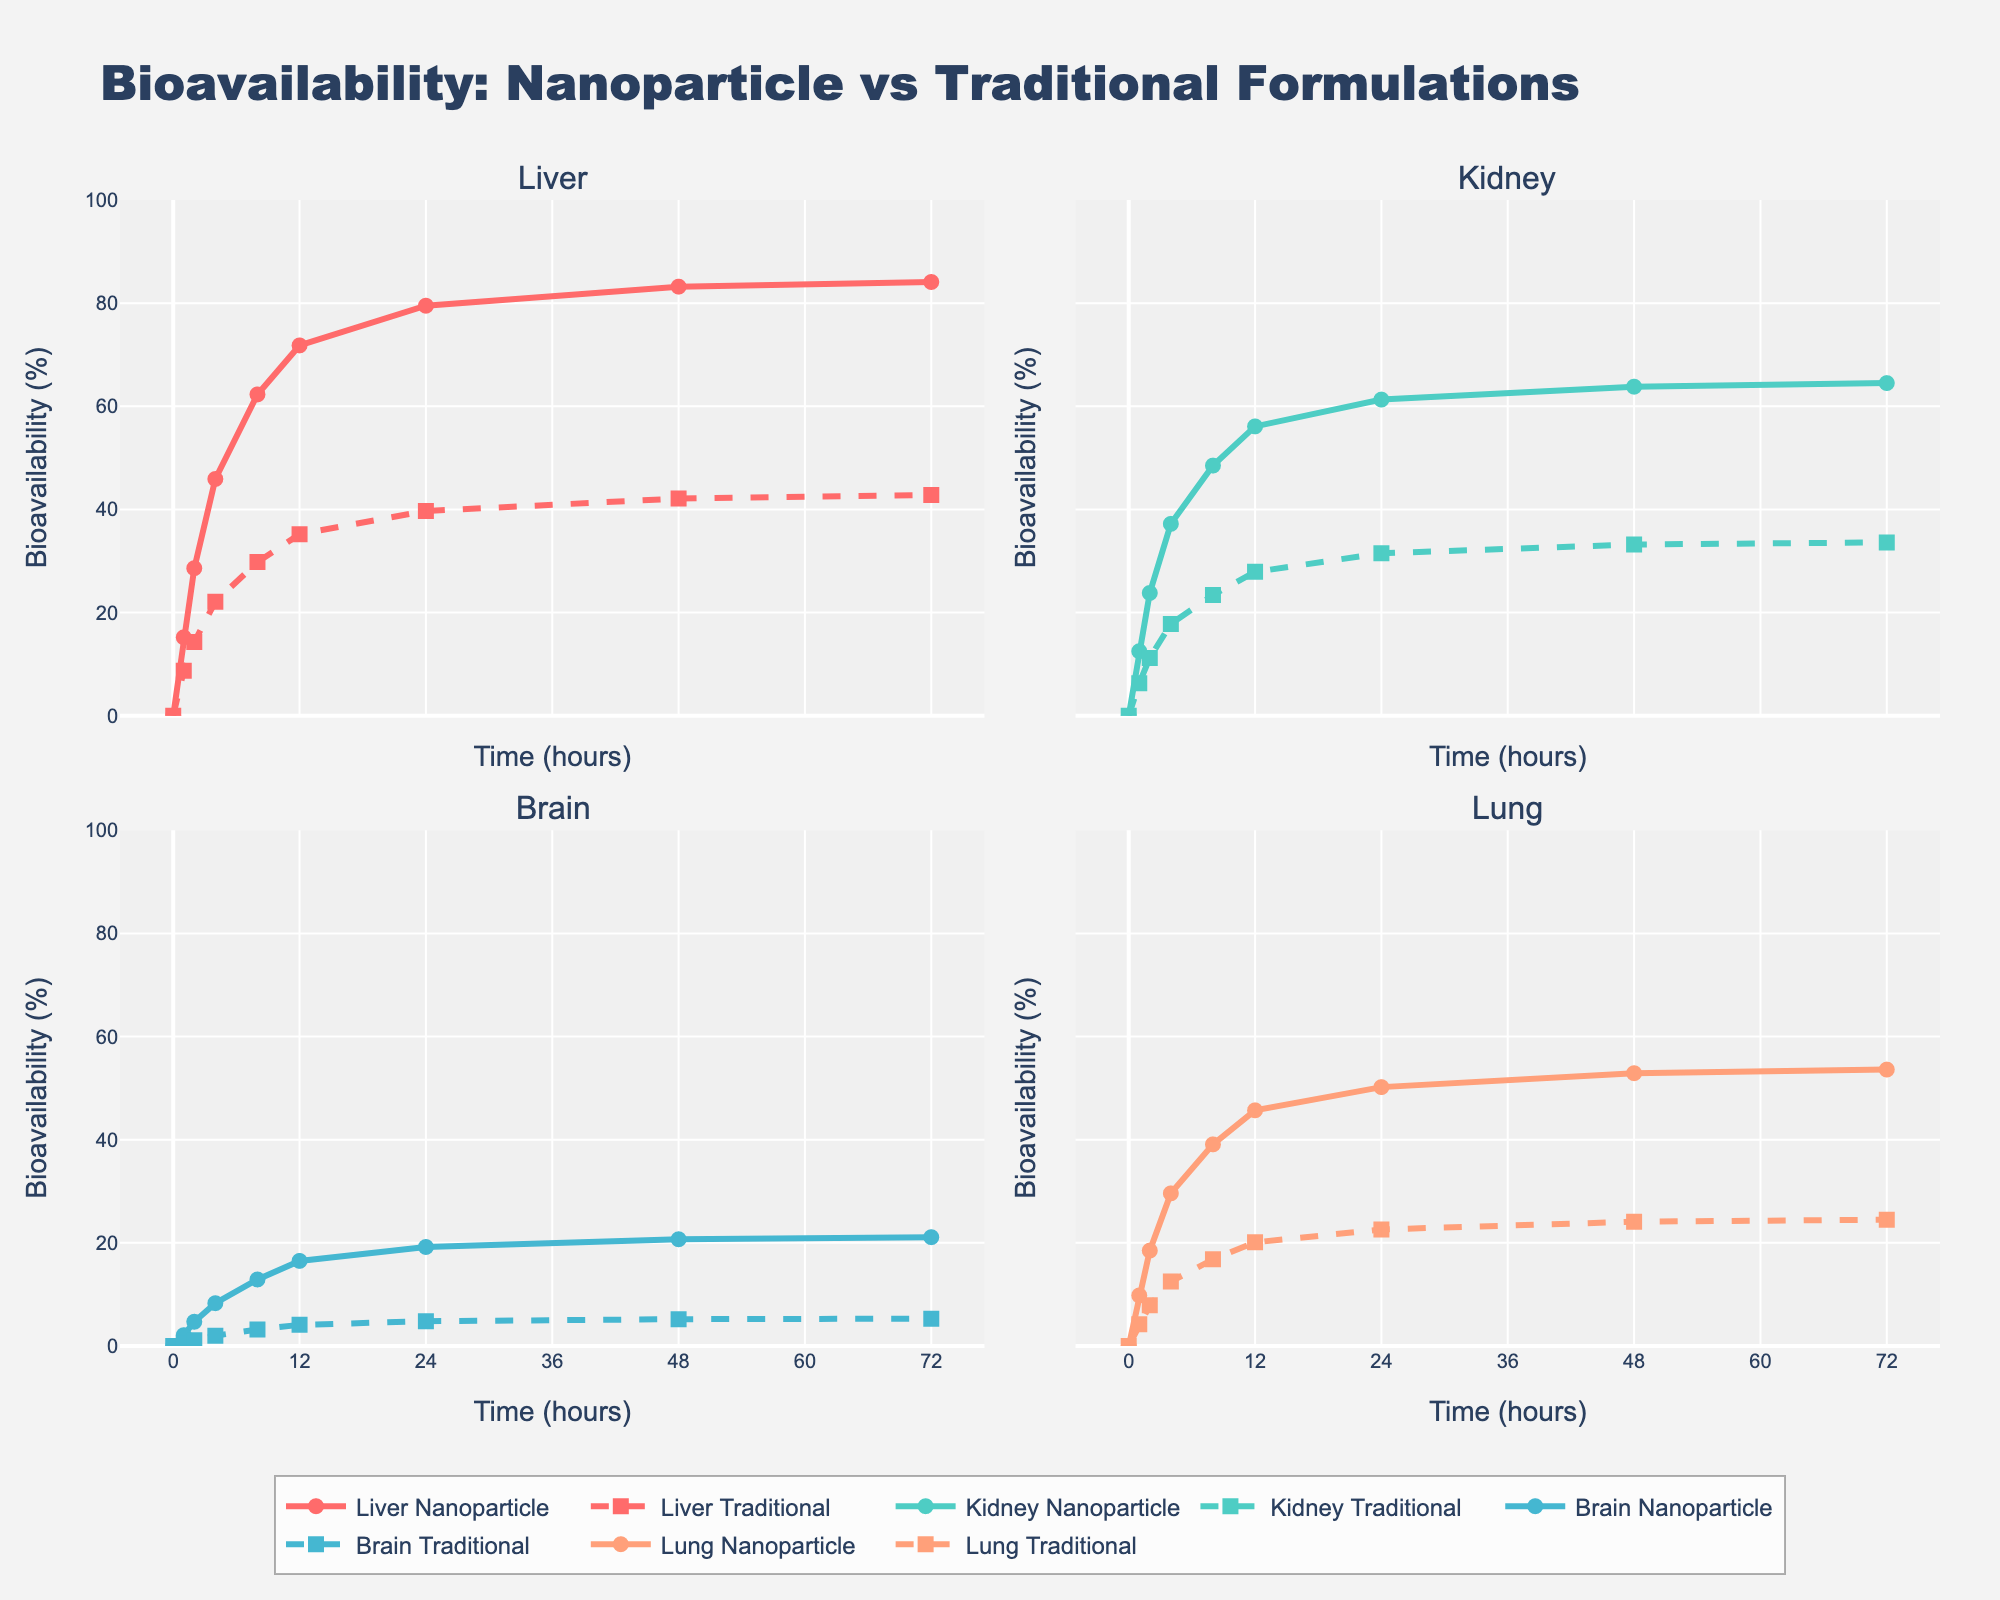What is the title of the scatterplot matrix? Look at the top of the plot, the title is displayed prominently.
Answer: Bridge Card Distribution Analysis How many dimensions of analysis are displayed in the scatterplot matrix? Count the number of unique column names used for the axes of the scatter plot matrix.
Answer: 5 Which hand distribution is represented by a yellow color in the scatter plot matrix? Look at the color bar legend on the plot. Correspond the color to the hand distribution label.
Answer: 5-3-3-2 What is the general relationship between High Card Points and Game Success Rate? Observe the scatter plot cells which combine High Card Points with Game Success Rate. Notice if the points trend upwards, downwards, or show no clear pattern.
Answer: Generally positive Which variable has the most spread out values when comparing No Trump Tricks and Major Suit Tricks? Compare the scatter plots involving No Trump Tricks and Major Suit Tricks, noting the dispersion of points.
Answer: Major Suit Tricks Do all points with High Card Points of 15 have the same Game Success Rate? Locate the scatter plot cell for High Card Points vs. Game Success Rate, and check the vertical line at 15 points for variability.
Answer: No What is the maximum value for Major Suit Tricks in the data? Look at the appropriate axes for the Major Suit Tricks across the relevant scatter plots, noting the highest value.
Answer: 6 What trend can be observed for No Trump Tricks when High Card Points increase from 10 to 16? Observe the scatter plot combination of No Trump Tricks and High Card Points, tracking points from 10 to 16 on the High Card Points axis.
Answer: Increasing trend Are there any hand distributions that consistently have a Game Success Rate above 0.70? Use the color and scatter plot markers across the Game Success Rate axis to find repeated success rates above 0.70 and correlate them back to hand distributions.
Answer: Yes Is there a visible correlation between Minor Suit Tricks and Game Success Rate? Examine the scatter plot cell for Minor Suit Tricks vs. Game Success Rate, noting if an upward or downward trend line can be inferred.
Answer: No clear correlation 